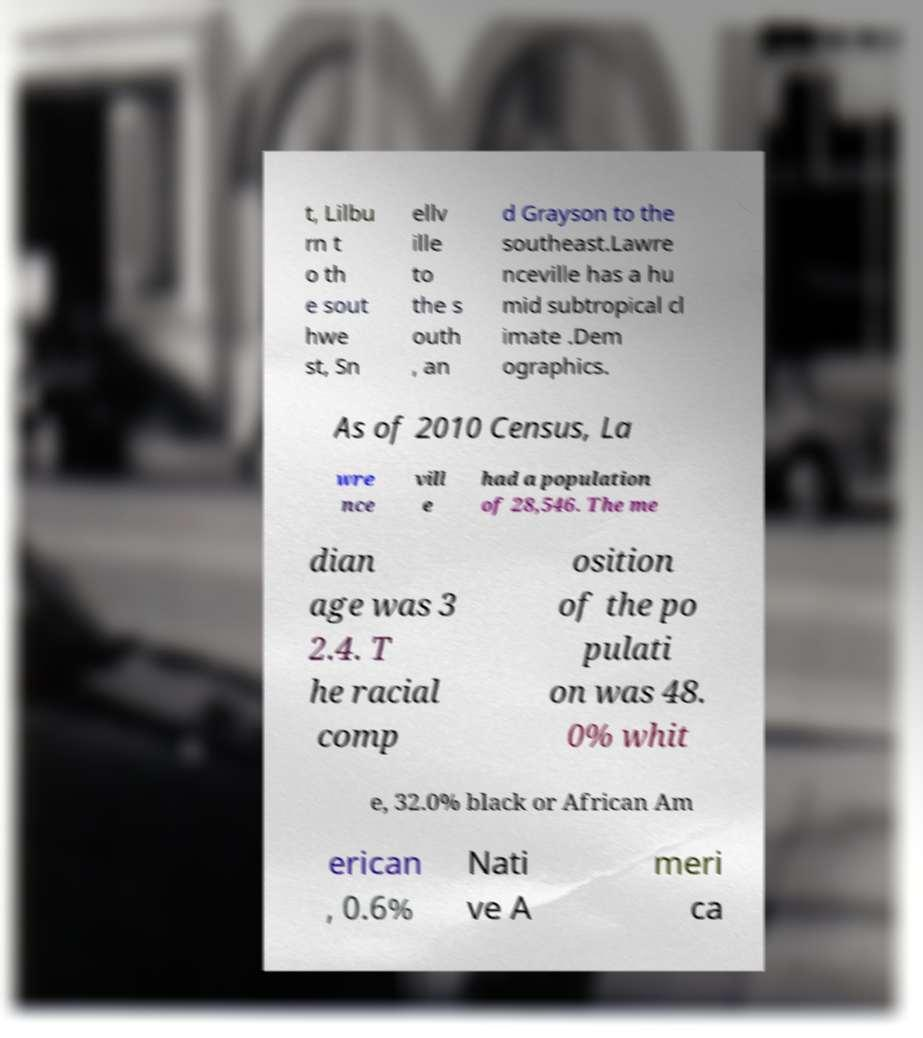There's text embedded in this image that I need extracted. Can you transcribe it verbatim? t, Lilbu rn t o th e sout hwe st, Sn ellv ille to the s outh , an d Grayson to the southeast.Lawre nceville has a hu mid subtropical cl imate .Dem ographics. As of 2010 Census, La wre nce vill e had a population of 28,546. The me dian age was 3 2.4. T he racial comp osition of the po pulati on was 48. 0% whit e, 32.0% black or African Am erican , 0.6% Nati ve A meri ca 